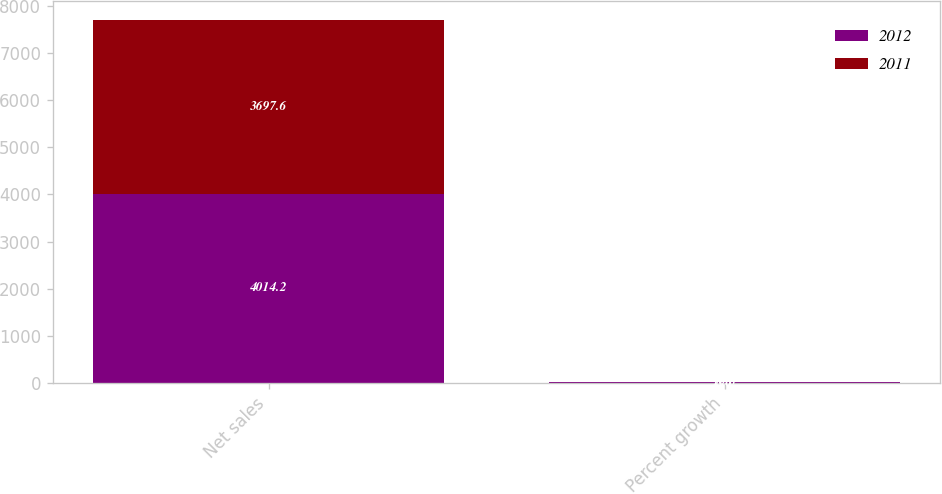<chart> <loc_0><loc_0><loc_500><loc_500><stacked_bar_chart><ecel><fcel>Net sales<fcel>Percent growth<nl><fcel>2012<fcel>4014.2<fcel>8.6<nl><fcel>2011<fcel>3697.6<fcel>10.8<nl></chart> 